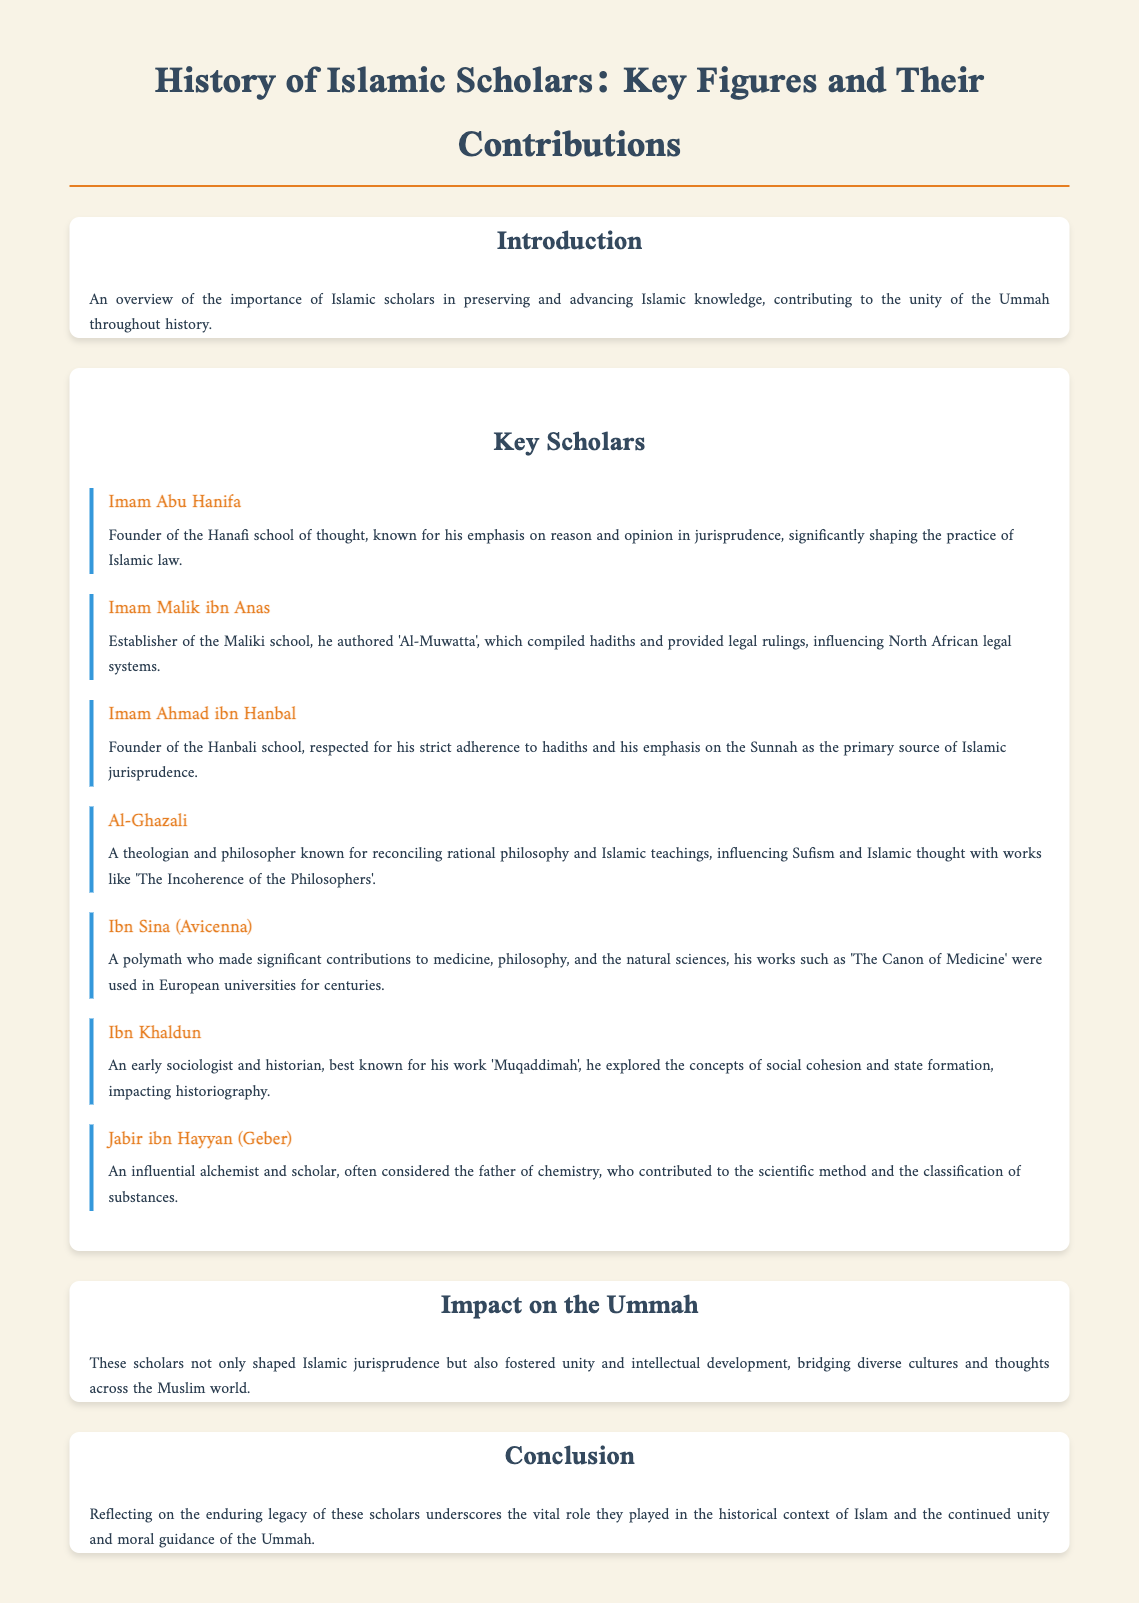What is the title of the document? The title of the document is located at the top and clearly states the subject matter.
Answer: History of Islamic Scholars: Key Figures and Their Contributions Who is the founder of the Hanafi school of thought? The founder of the Hanafi school of thought is mentioned in the section on key scholars.
Answer: Imam Abu Hanifa Which scholar established the Maliki school? The document specifically states who established the Maliki school and mentions a significant work of that scholar.
Answer: Imam Malik ibn Anas What work is Ibn Khaldun best known for? The document provides the name of the prominent work attributed to Ibn Khaldun in the key scholars section.
Answer: Muqaddimah How did Al-Ghazali influence Islamic thought? The document describes Al-Ghazali's contributions, especially focusing on his reconciliation of certain fields.
Answer: Reconciling rational philosophy and Islamic teachings What main theme do these scholars share regarding the Ummah? The impact section discusses the common theme among the scholars in relation to the Ummah.
Answer: Unity and intellectual development What field is Jabir ibn Hayyan considered the father of? The document highlights Jabir ibn Hayyan's contributions in a specific scientific field, as mentioned in his details.
Answer: Chemistry Which scholar is known for his work in medicine? The document explicitly identifies a scholar whose contributions to the field of medicine are noted.
Answer: Ibn Sina (Avicenna) 